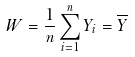Convert formula to latex. <formula><loc_0><loc_0><loc_500><loc_500>W = \frac { 1 } { n } \sum _ { i = 1 } ^ { n } Y _ { i } = \overline { Y }</formula> 